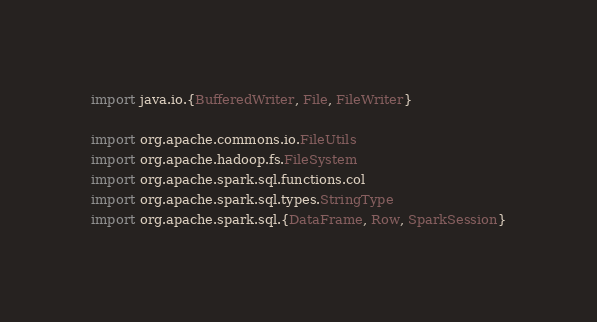<code> <loc_0><loc_0><loc_500><loc_500><_Scala_>import java.io.{BufferedWriter, File, FileWriter}

import org.apache.commons.io.FileUtils
import org.apache.hadoop.fs.FileSystem
import org.apache.spark.sql.functions.col
import org.apache.spark.sql.types.StringType
import org.apache.spark.sql.{DataFrame, Row, SparkSession}</code> 